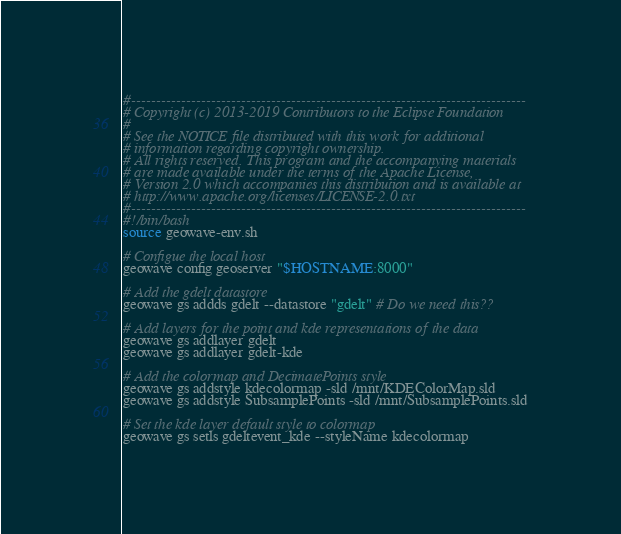<code> <loc_0><loc_0><loc_500><loc_500><_Bash_>#-------------------------------------------------------------------------------
# Copyright (c) 2013-2019 Contributors to the Eclipse Foundation
# 
# See the NOTICE file distributed with this work for additional
# information regarding copyright ownership.
# All rights reserved. This program and the accompanying materials
# are made available under the terms of the Apache License,
# Version 2.0 which accompanies this distribution and is available at
# http://www.apache.org/licenses/LICENSE-2.0.txt
#-------------------------------------------------------------------------------
#!/bin/bash
source geowave-env.sh

# Configue the local host
geowave config geoserver "$HOSTNAME:8000"

# Add the gdelt datastore 
geowave gs addds gdelt --datastore "gdelt" # Do we need this??

# Add layers for the point and kde representations of the data
geowave gs addlayer gdelt
geowave gs addlayer gdelt-kde

# Add the colormap and DecimatePoints style
geowave gs addstyle kdecolormap -sld /mnt/KDEColorMap.sld
geowave gs addstyle SubsamplePoints -sld /mnt/SubsamplePoints.sld

# Set the kde layer default style to colormap
geowave gs setls gdeltevent_kde --styleName kdecolormap

</code> 